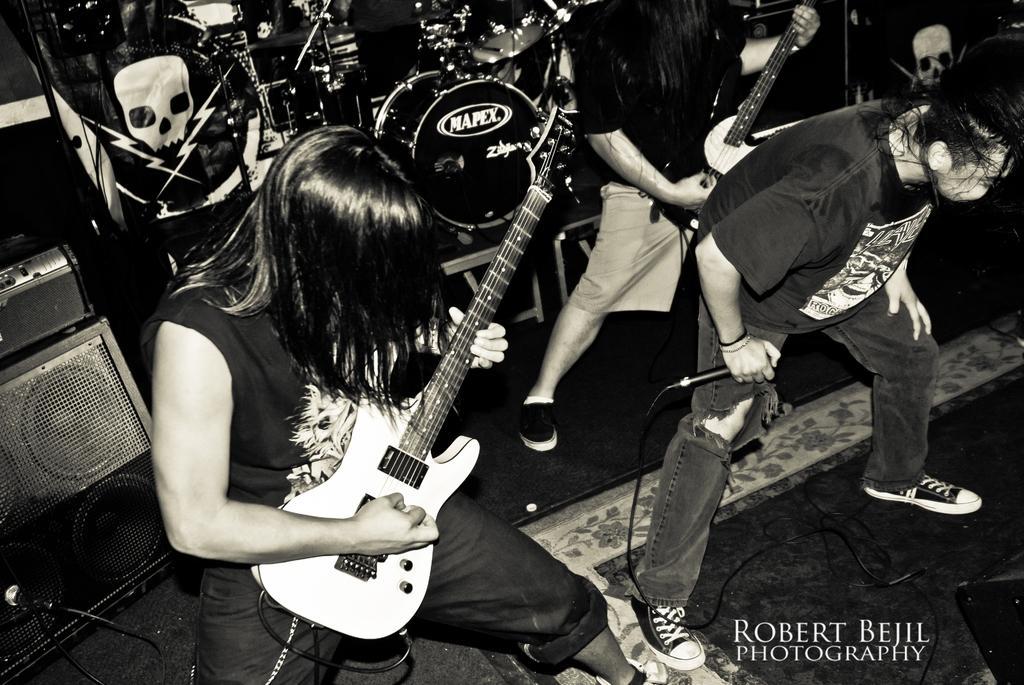In one or two sentences, can you explain what this image depicts? In this picture we can see three persons where two are holding guitars in their hand and playing and one is holding mic in his hand and bending and in background we can see drums, banner, speakers, wires. 